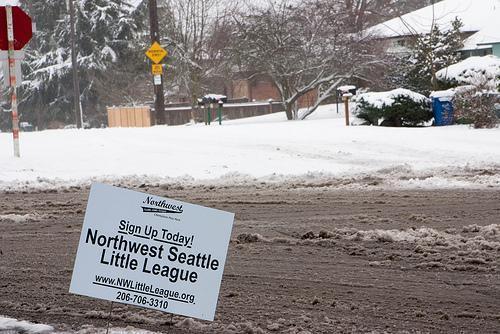How many stop signs are in the picture?
Give a very brief answer. 1. 